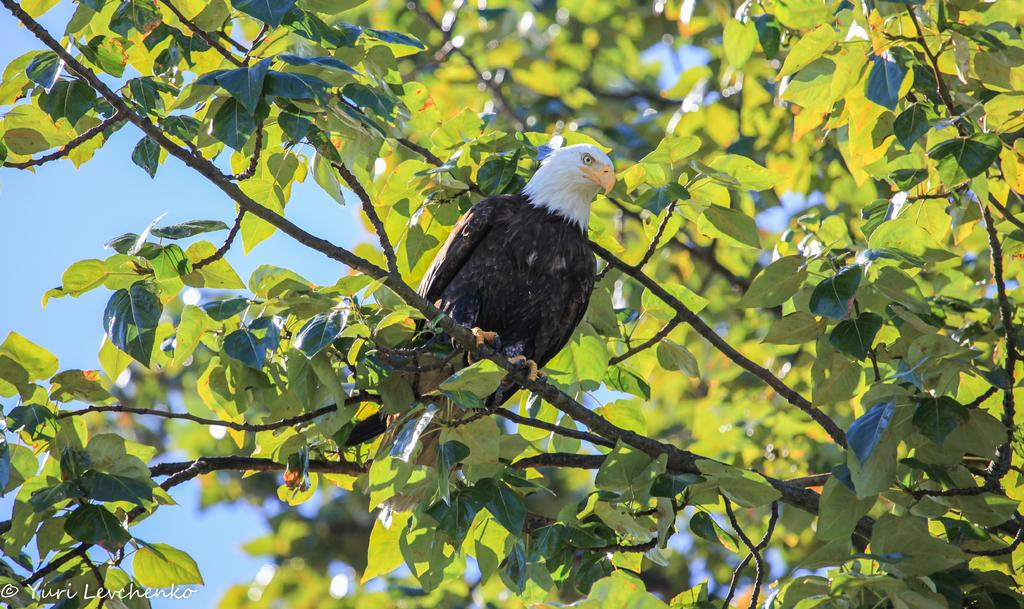What type of animal can be seen in the image? There is a bird on the tree in the image. What can be seen in the background of the image? The sky is visible in the background of the image. What is present at the bottom of the image? There is text at the bottom of the image. What type of fruit is hanging from the tree in the image? There is no fruit visible on the tree in the image; only the bird can be seen. 